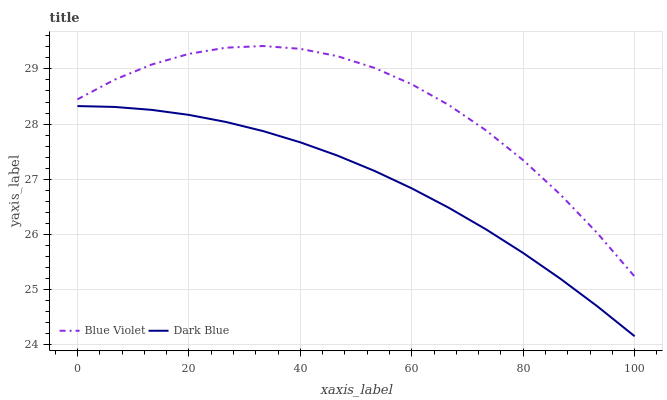Does Dark Blue have the minimum area under the curve?
Answer yes or no. Yes. Does Blue Violet have the maximum area under the curve?
Answer yes or no. Yes. Does Blue Violet have the minimum area under the curve?
Answer yes or no. No. Is Dark Blue the smoothest?
Answer yes or no. Yes. Is Blue Violet the roughest?
Answer yes or no. Yes. Is Blue Violet the smoothest?
Answer yes or no. No. Does Dark Blue have the lowest value?
Answer yes or no. Yes. Does Blue Violet have the lowest value?
Answer yes or no. No. Does Blue Violet have the highest value?
Answer yes or no. Yes. Is Dark Blue less than Blue Violet?
Answer yes or no. Yes. Is Blue Violet greater than Dark Blue?
Answer yes or no. Yes. Does Dark Blue intersect Blue Violet?
Answer yes or no. No. 